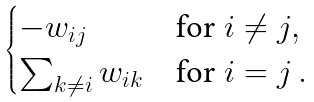Convert formula to latex. <formula><loc_0><loc_0><loc_500><loc_500>\begin{cases} - w _ { i j } & \text {for } i \neq j , \\ \sum _ { k \neq i } w _ { i k } & \text {for } i = j \, . \end{cases}</formula> 